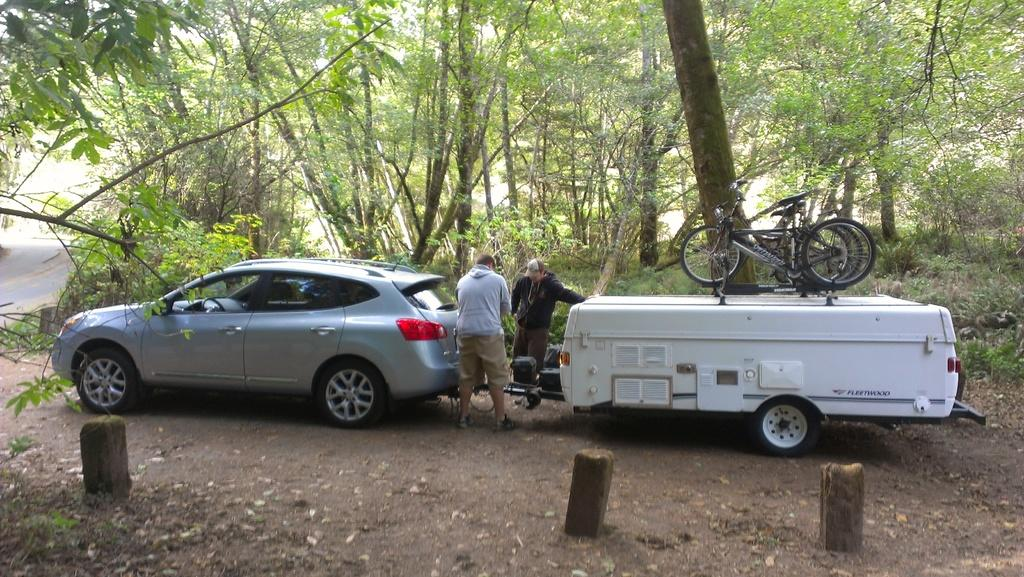What is the main subject of the image? There is a car in the image. Can you describe the people in the image? There are two people standing on the ground. What type of vehicle is present in the image besides the car? There is a vehicle with bicycles on it. What can be seen in the background of the image? There is a road visible in the background. What type of natural environment is present in the image? There are trees, grass, and poles in the image. What type of flower is growing on the car in the image? There are no flowers present on the car in the image. Can you tell me how many eggs are visible in the image? There are no eggs present in the image. 